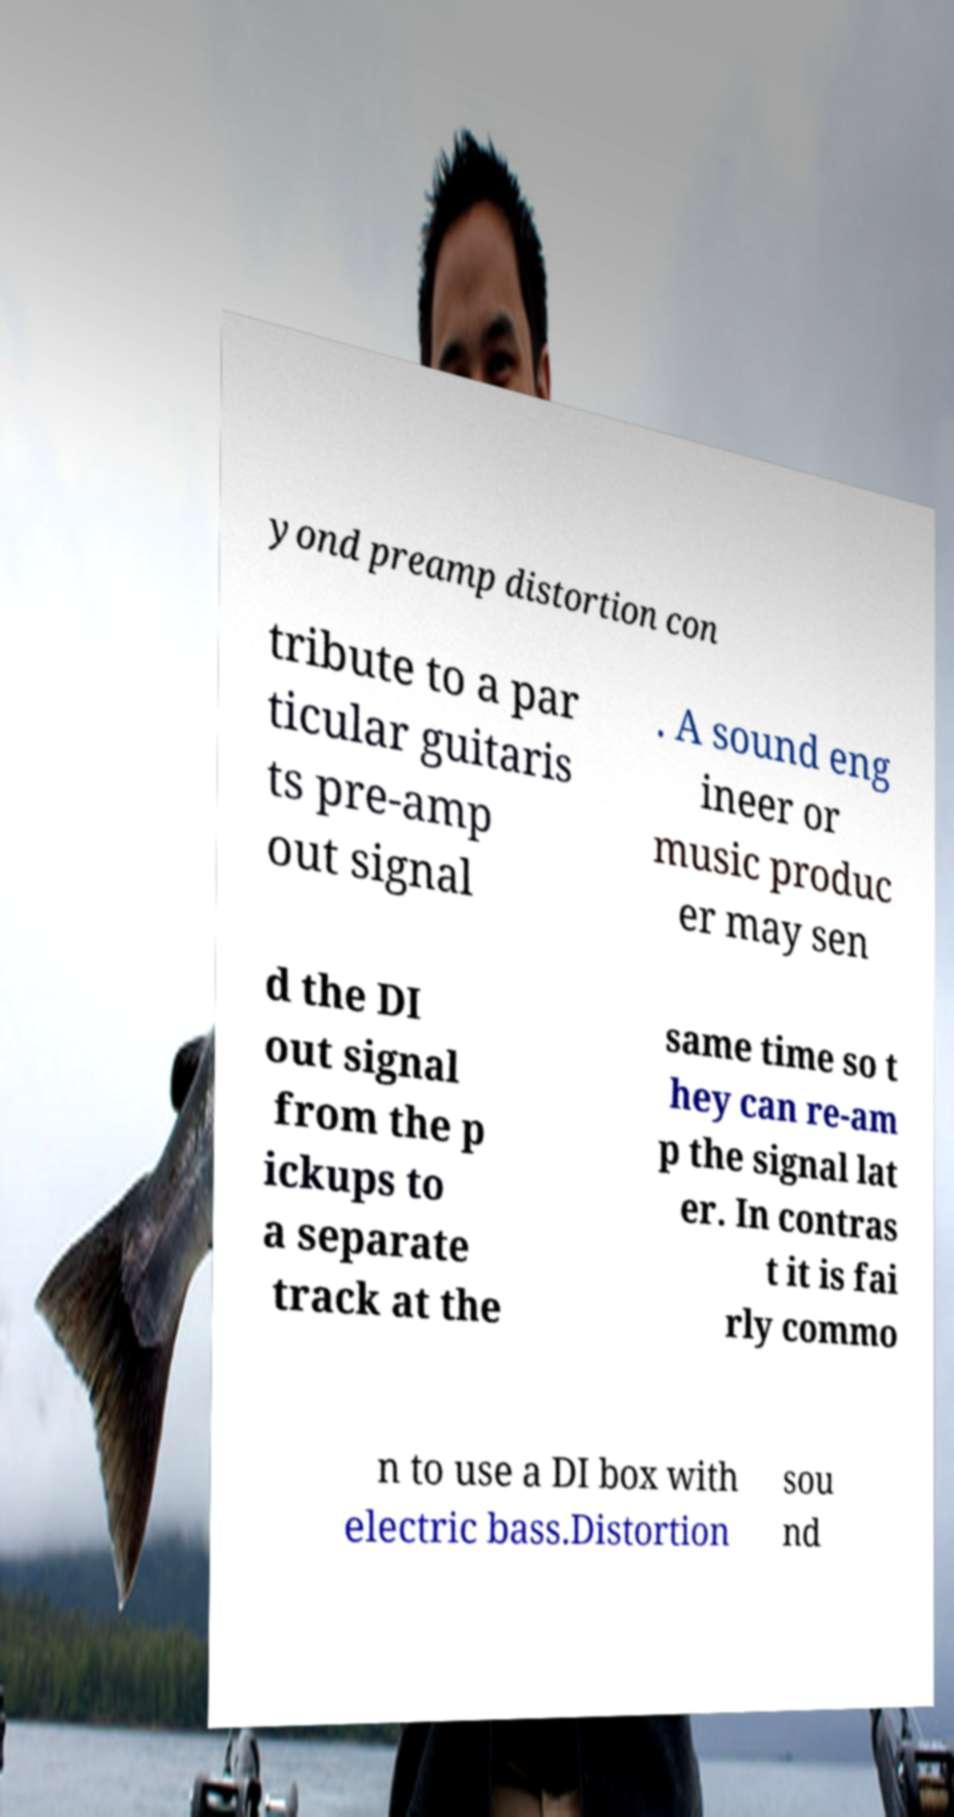Can you accurately transcribe the text from the provided image for me? yond preamp distortion con tribute to a par ticular guitaris ts pre-amp out signal . A sound eng ineer or music produc er may sen d the DI out signal from the p ickups to a separate track at the same time so t hey can re-am p the signal lat er. In contras t it is fai rly commo n to use a DI box with electric bass.Distortion sou nd 